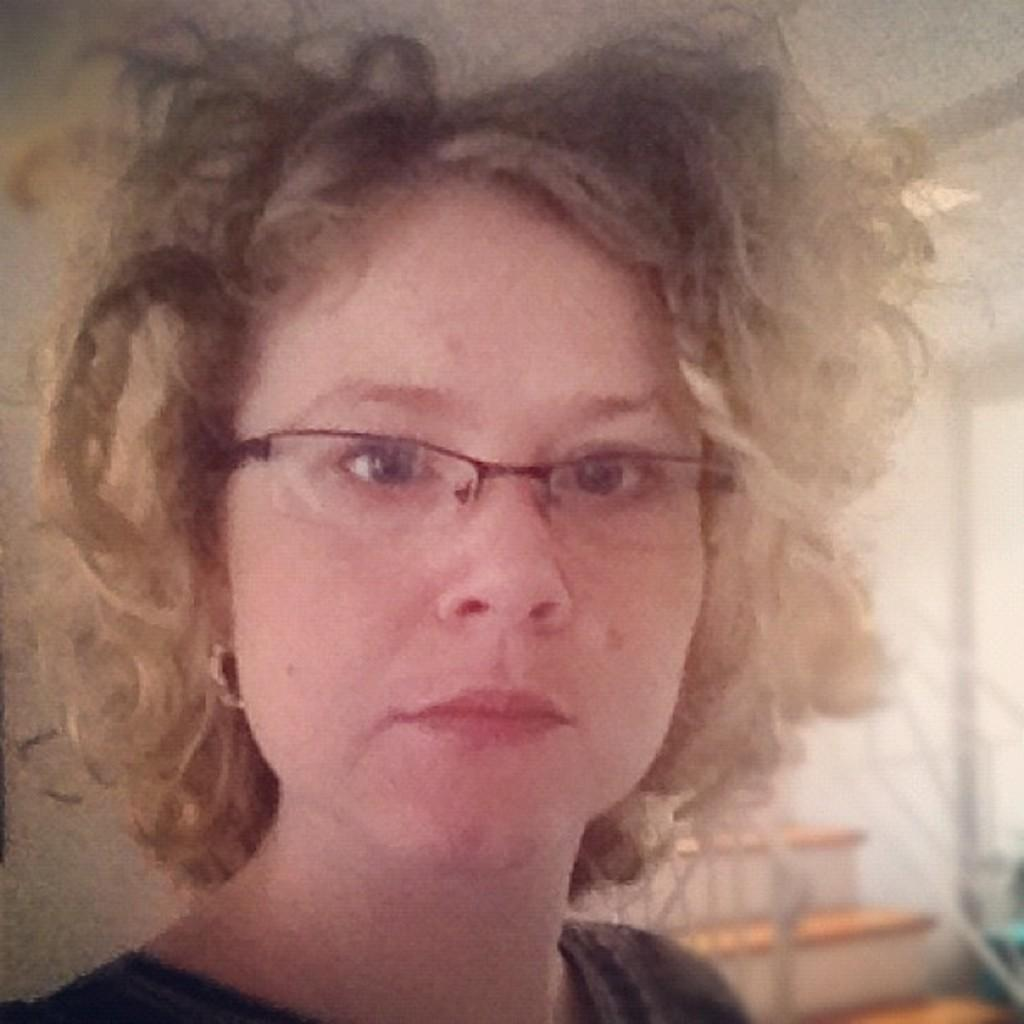What is the main subject of the image? There is a woman's face in the front of the image. What can be seen on the woman's face? The woman is wearing spectacles. What architectural feature is visible in the background of the image? There are stairs in the background of the image. What type of harmony is being played in the background of the image? There is no music or harmony present in the image; it features a woman's face and stairs in the background. What color is the gold object in the image? There is no gold object present in the image. 